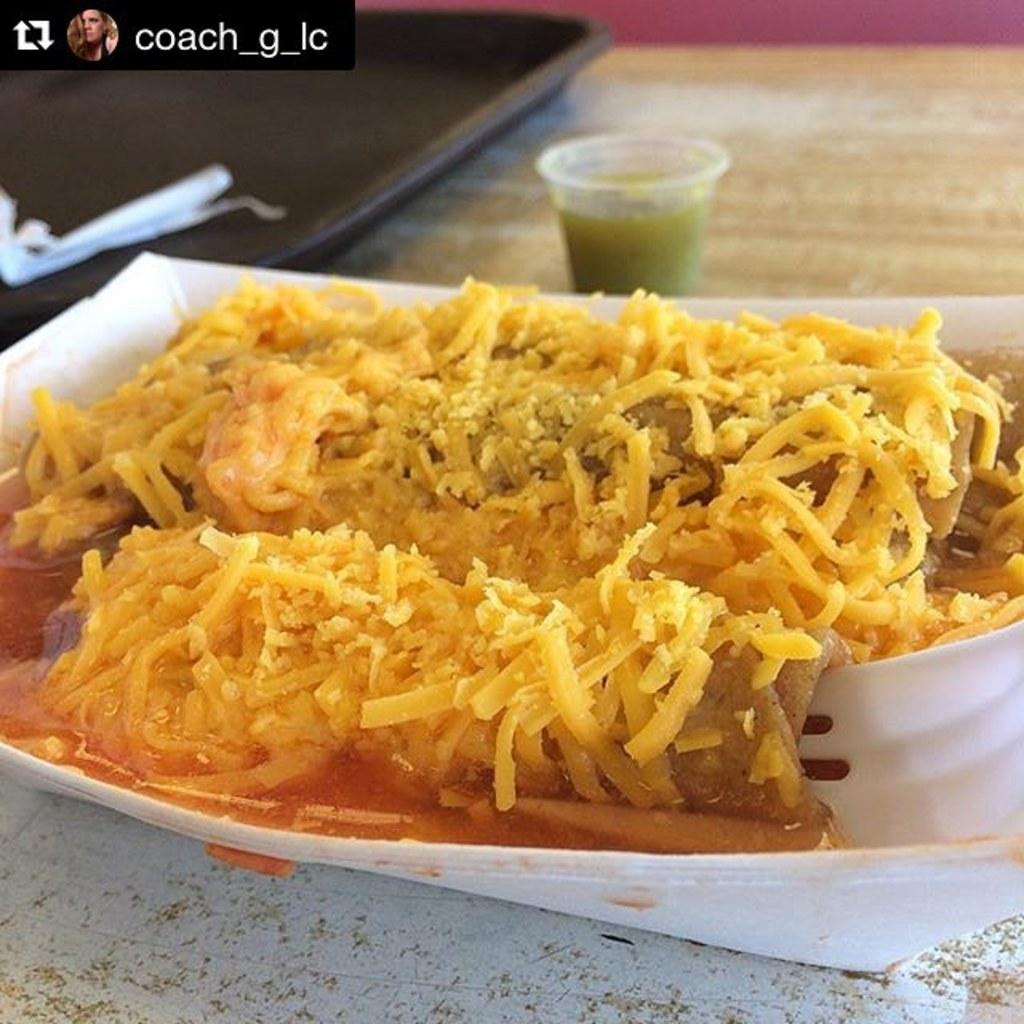What is on the plate that is visible in the image? There is food on a plate in the image. Where is the plate located in the image? The plate is in the center of the image. How many spiders are crawling on the train in the image? There is no train or spiders present in the image; it only features a plate of food. 